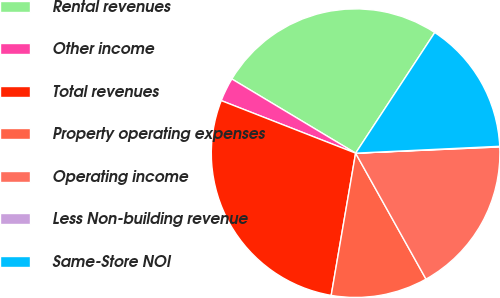Convert chart. <chart><loc_0><loc_0><loc_500><loc_500><pie_chart><fcel>Rental revenues<fcel>Other income<fcel>Total revenues<fcel>Property operating expenses<fcel>Operating income<fcel>Less Non-building revenue<fcel>Same-Store NOI<nl><fcel>25.65%<fcel>2.66%<fcel>28.23%<fcel>10.82%<fcel>17.58%<fcel>0.07%<fcel>15.0%<nl></chart> 